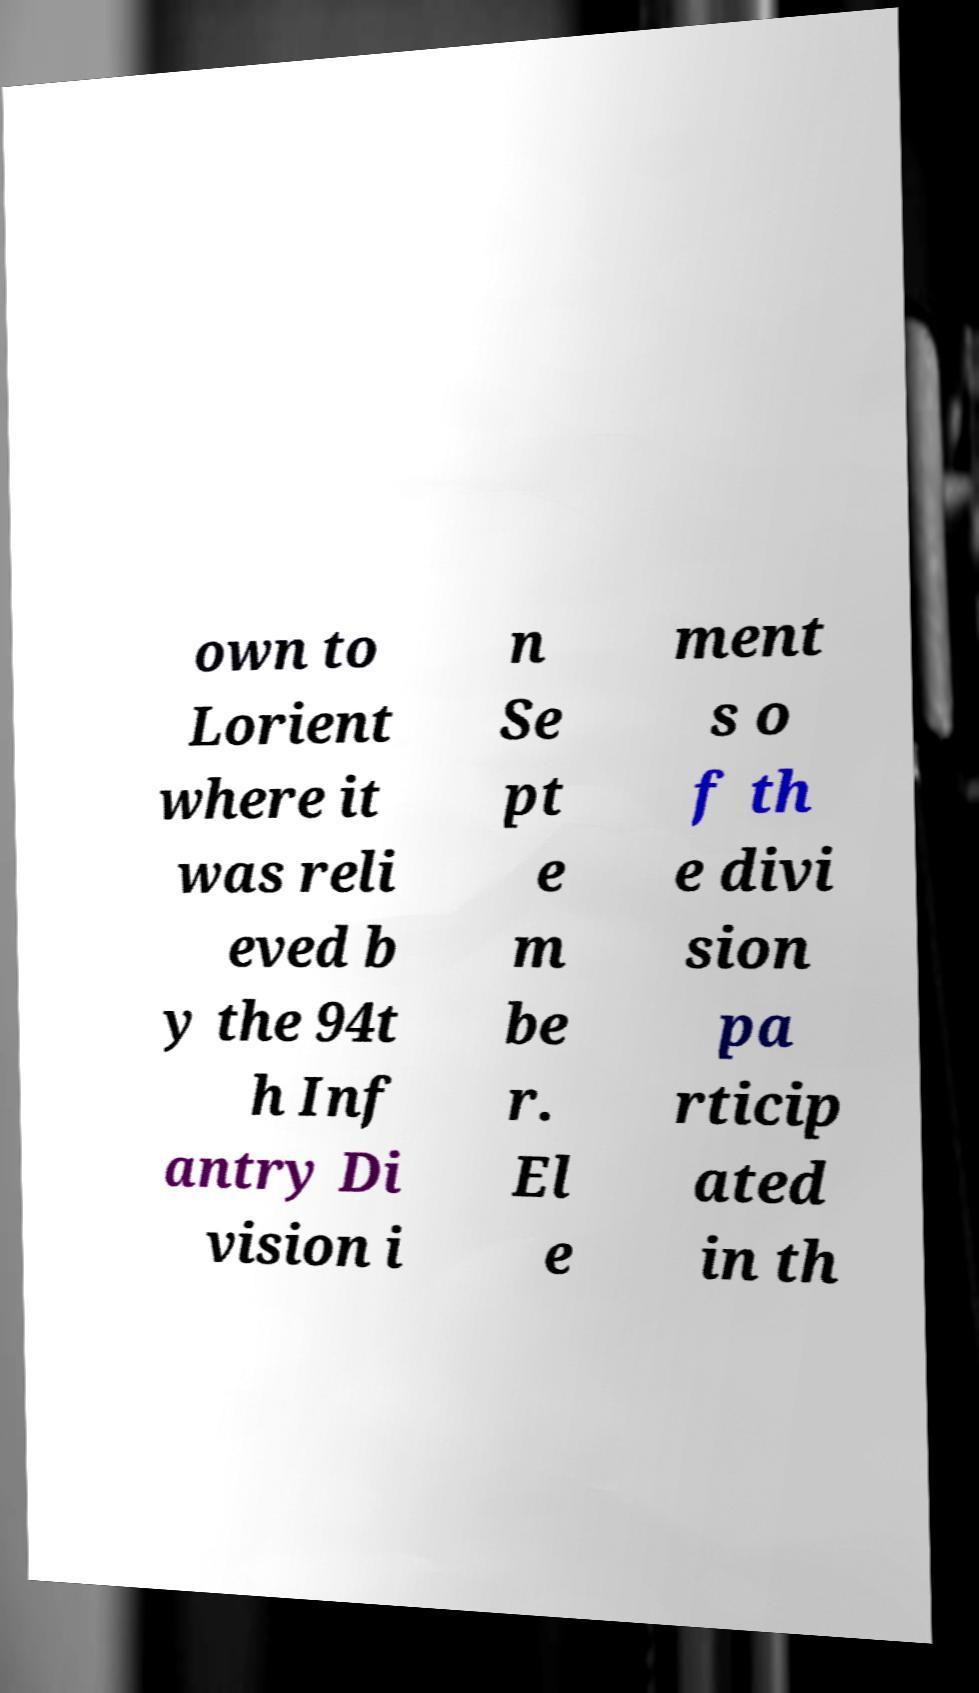For documentation purposes, I need the text within this image transcribed. Could you provide that? own to Lorient where it was reli eved b y the 94t h Inf antry Di vision i n Se pt e m be r. El e ment s o f th e divi sion pa rticip ated in th 